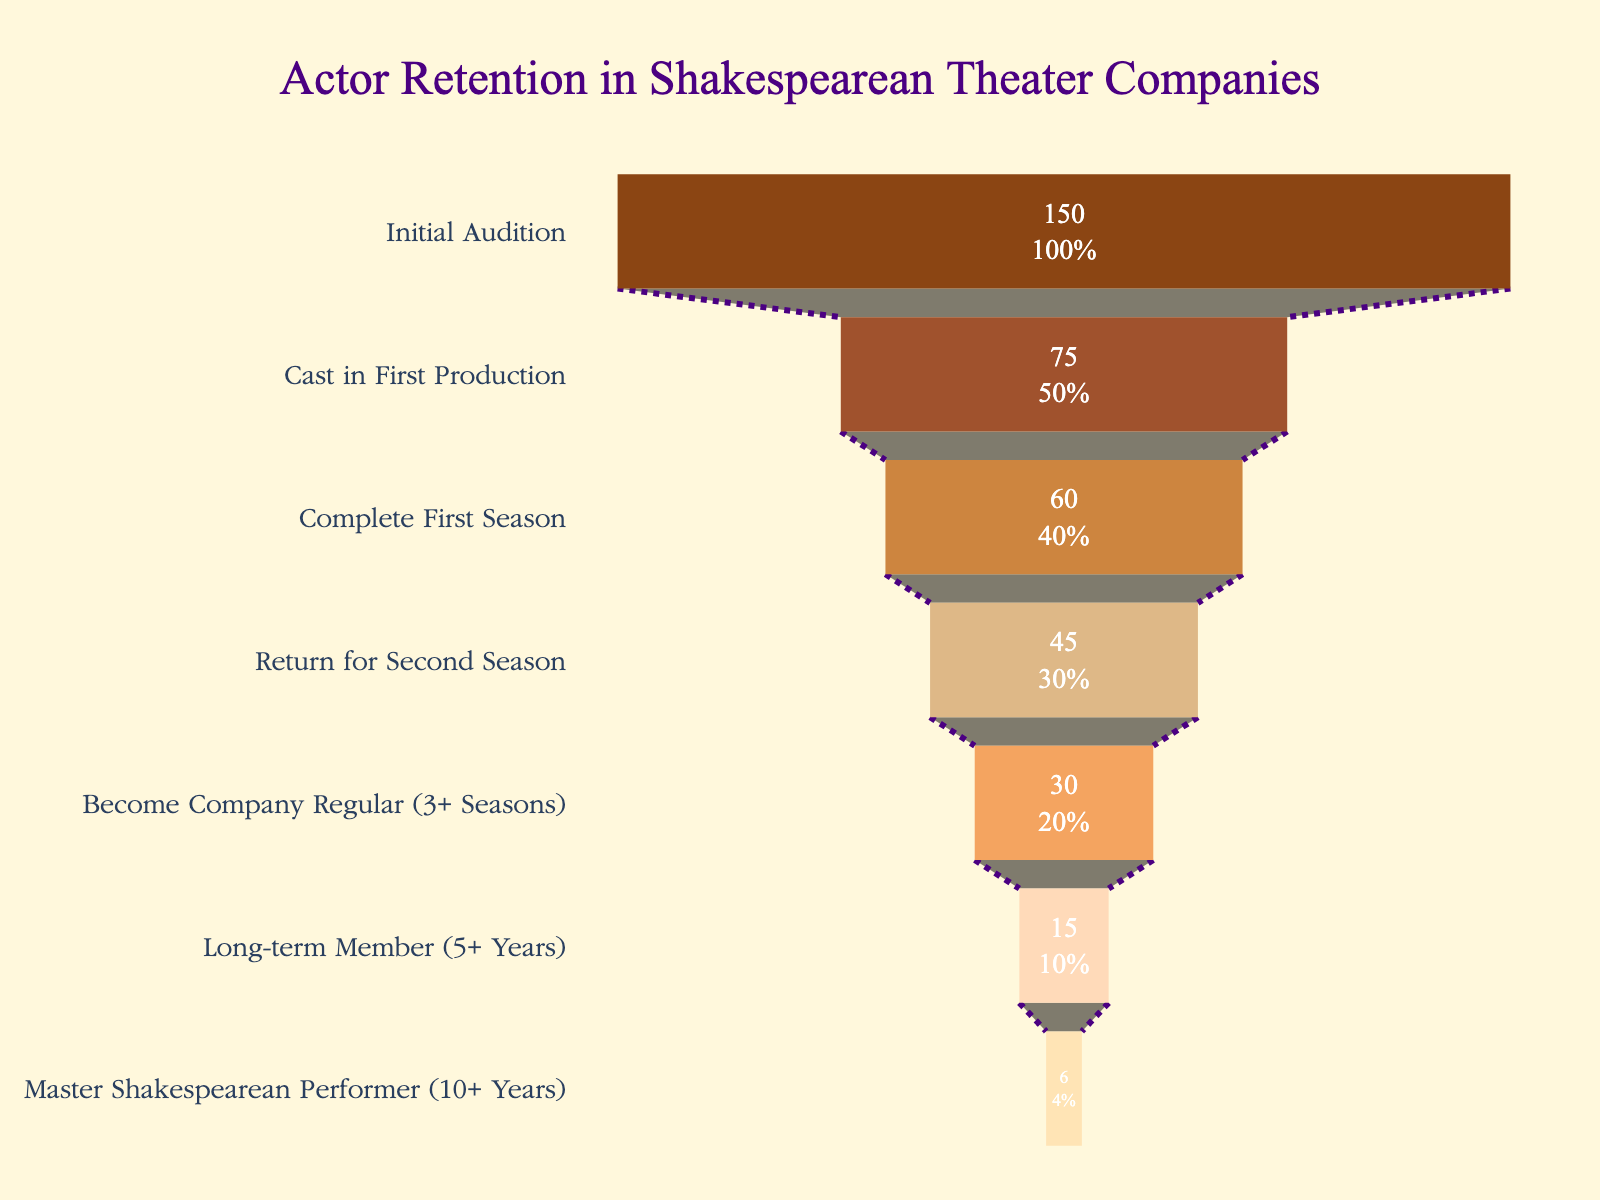what is the title of this figure? The title of the figure is centered at the top. It reads: "Actor Retention in Shakespearean Theater Companies"
Answer: Actor Retention in Shakespearean Theater Companies How many stages are represented in the funnel chart? The funnel chart has multiple segments, each representing a different stage of actor retention. Counting these segments shows there are seven stages.
Answer: Seven What percentage of actors make it past the initial audition? The top segment of the funnel represents "Initial Audition" and shows that 100% make it past this stage; this is the starting point.
Answer: 100% Which stage has the highest number of actors retained, and how many? The first stage, "Initial Audition," has the highest number of actors retained, as indicated by a value of 150 actors.
Answer: Initial Audition, 150 actors What is the total number of actors who become long-term members after 5+ years? The second-to-last stage labeled "Long-term Member (5+ Years)" indicates the number, which is 15 actors.
Answer: 15 What is the difference in the number of actors retained between the "Initial Audition" and "Master Shakespearean Performer (10+ Years)" stages? The "Initial Audition" stage has 150 actors, and the "Master Shakespearean Performer (10+ Years)" stage has 6 actors. Subtracting 6 from 150 gives the difference.
Answer: 144 What percentage of actors who complete the first season return for the second season? At "Complete First Season," there are 60 actors. "Return for Second Season" retains 45. The percentage is calculated as (45/60) * 100%.
Answer: 75% Which stage represents a drop of 50% in actor retention? The second stage "Cast in First Production" shows that 50% of actors (75 out of 150) are retained from the first stage, indicating a 50% drop.
Answer: Cast in First Production What is the numerical drop in the number of actors from "Cast in First Production" to "Complete First Season"? "Cast in First Production" has 75 actors, and "Complete First Season" retains 60. Subtracting 60 from 75 gives the numerical drop.
Answer: 15 How does the annotation at the bottom of the chart relate to Shakespeare's work? The annotation quotes a famous line from "As You Like It," emphasizing the metaphor that life is like a stage, which ties into the retention journey of actors in a theater company.
Answer: It quotes "As You Like It" and ties into the actor's journey 